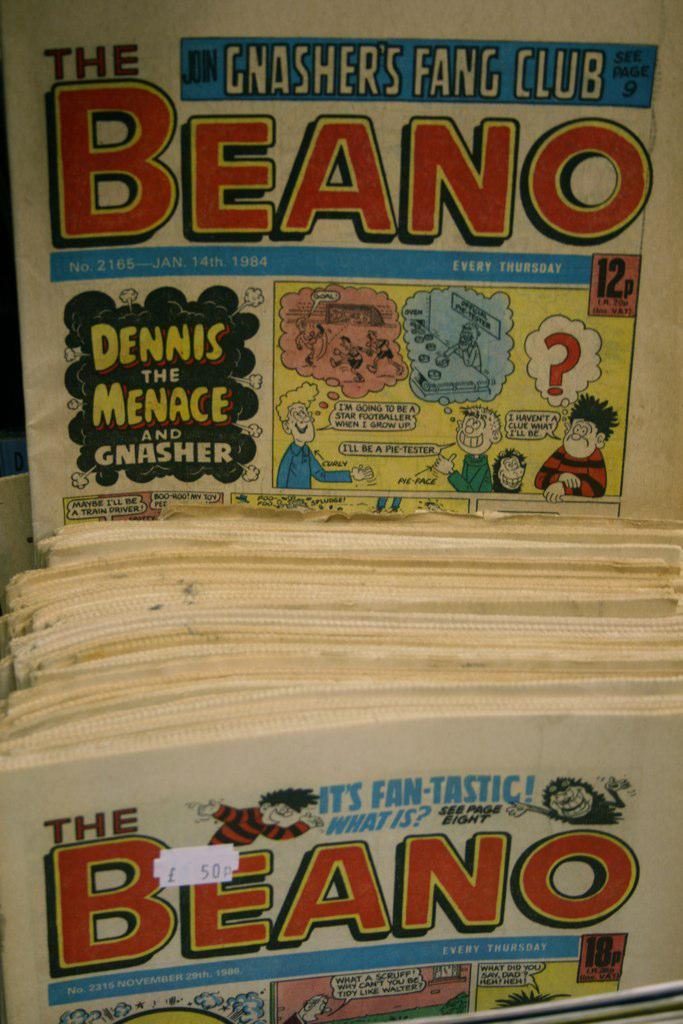What's the name of this comic?
Give a very brief answer. The beano. 